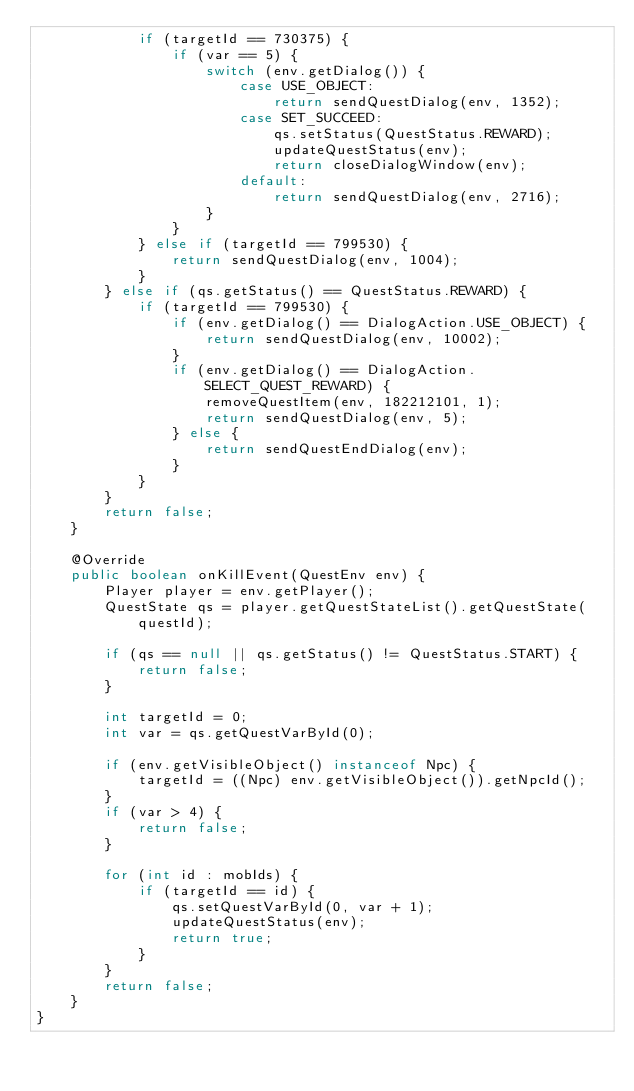Convert code to text. <code><loc_0><loc_0><loc_500><loc_500><_Java_>            if (targetId == 730375) {
                if (var == 5) {
                    switch (env.getDialog()) {
                        case USE_OBJECT:
                            return sendQuestDialog(env, 1352);
                        case SET_SUCCEED:
                            qs.setStatus(QuestStatus.REWARD);
                            updateQuestStatus(env);
                            return closeDialogWindow(env);
                        default:
                            return sendQuestDialog(env, 2716);
                    }
                }
            } else if (targetId == 799530) {
                return sendQuestDialog(env, 1004);
            }
        } else if (qs.getStatus() == QuestStatus.REWARD) {
            if (targetId == 799530) {
                if (env.getDialog() == DialogAction.USE_OBJECT) {
                    return sendQuestDialog(env, 10002);
                }
                if (env.getDialog() == DialogAction.SELECT_QUEST_REWARD) {
                    removeQuestItem(env, 182212101, 1);
                    return sendQuestDialog(env, 5);
                } else {
                    return sendQuestEndDialog(env);
                }
            }
        }
        return false;
    }

    @Override
    public boolean onKillEvent(QuestEnv env) {
        Player player = env.getPlayer();
        QuestState qs = player.getQuestStateList().getQuestState(questId);

        if (qs == null || qs.getStatus() != QuestStatus.START) {
            return false;
        }

        int targetId = 0;
        int var = qs.getQuestVarById(0);

        if (env.getVisibleObject() instanceof Npc) {
            targetId = ((Npc) env.getVisibleObject()).getNpcId();
        }
        if (var > 4) {
            return false;
        }

        for (int id : mobIds) {
            if (targetId == id) {
                qs.setQuestVarById(0, var + 1);
                updateQuestStatus(env);
                return true;
            }
        }
        return false;
    }
}
</code> 